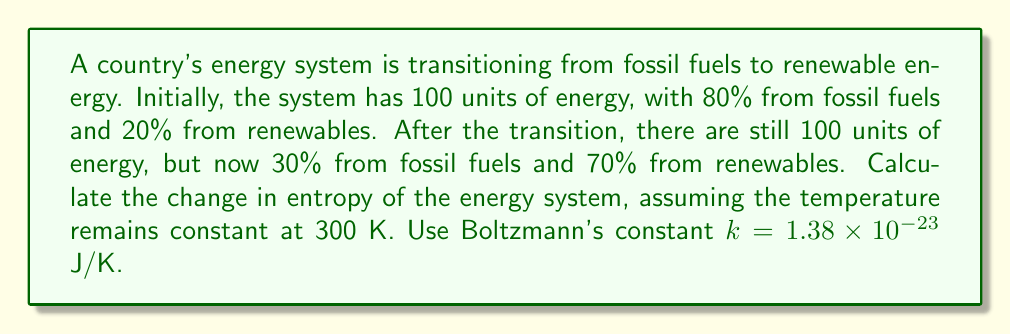Provide a solution to this math problem. To calculate the change in entropy, we'll use the formula for entropy in a two-state system:

$S = -k \sum_{i} p_i \ln(p_i)$

Where $k$ is Boltzmann's constant, and $p_i$ is the probability of being in state $i$.

Step 1: Calculate initial entropy
$S_i = -k[(0.8 \ln(0.8) + 0.2 \ln(0.2)]$
$S_i = -(1.38 \times 10^{-23})[(0.8 \times (-0.223) + 0.2 \times (-1.609))]$
$S_i = -(1.38 \times 10^{-23})(-0.5002)$
$S_i = 6.903 \times 10^{-24}$ J/K

Step 2: Calculate final entropy
$S_f = -k[(0.3 \ln(0.3) + 0.7 \ln(0.7)]$
$S_f = -(1.38 \times 10^{-23})[(0.3 \times (-1.204) + 0.7 \times (-0.357))]$
$S_f = -(1.38 \times 10^{-23})(-0.6111)$
$S_f = 8.433 \times 10^{-24}$ J/K

Step 3: Calculate change in entropy
$\Delta S = S_f - S_i$
$\Delta S = (8.433 \times 10^{-24}) - (6.903 \times 10^{-24})$
$\Delta S = 1.53 \times 10^{-24}$ J/K

Step 4: Multiply by temperature to get entropy change
$\Delta S_{total} = \Delta S \times T$
$\Delta S_{total} = (1.53 \times 10^{-24}) \times 300$
$\Delta S_{total} = 4.59 \times 10^{-22}$ J
Answer: $4.59 \times 10^{-22}$ J 